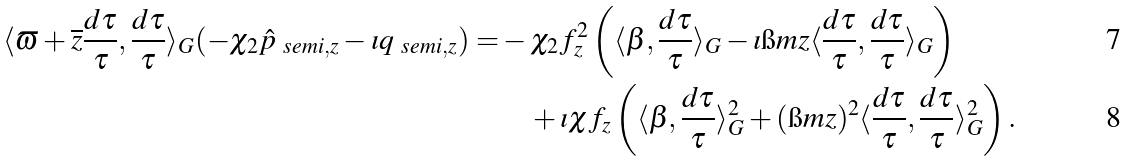Convert formula to latex. <formula><loc_0><loc_0><loc_500><loc_500>\langle \varpi + \overline { z } \frac { d \tau } { \tau } , \frac { d \tau } { \tau } \rangle _ { G } ( - \chi _ { 2 } \hat { p } _ { \ s e m i , z } - \imath q _ { \ s e m i , z } ) = & - \chi _ { 2 } f _ { z } ^ { 2 } \left ( \langle \beta , \frac { d \tau } { \tau } \rangle _ { G } - \imath \i m z \langle \frac { d \tau } { \tau } , \frac { d \tau } { \tau } \rangle _ { G } \right ) \\ & \quad + \imath \chi f _ { z } \left ( \langle \beta , \frac { d \tau } { \tau } \rangle _ { G } ^ { 2 } + ( \i m z ) ^ { 2 } \langle \frac { d \tau } { \tau } , \frac { d \tau } { \tau } \rangle _ { G } ^ { 2 } \right ) .</formula> 